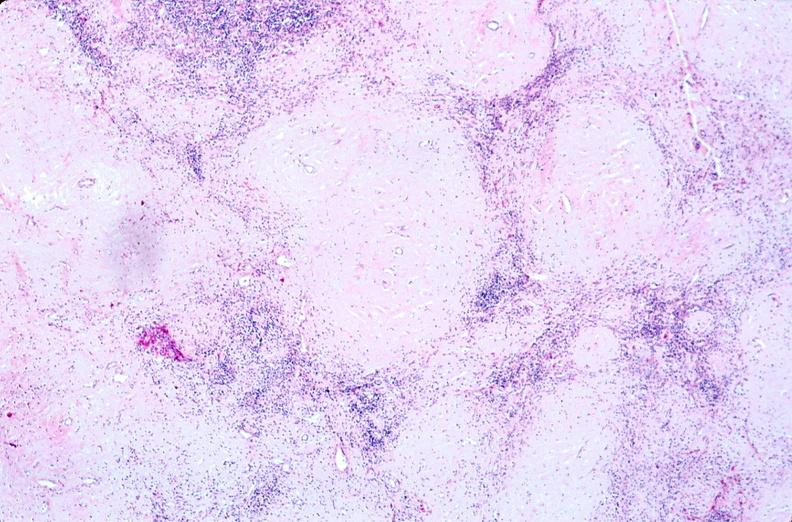does this image show lymph nodes, nodular sclerosing hodgkins disease?
Answer the question using a single word or phrase. Yes 